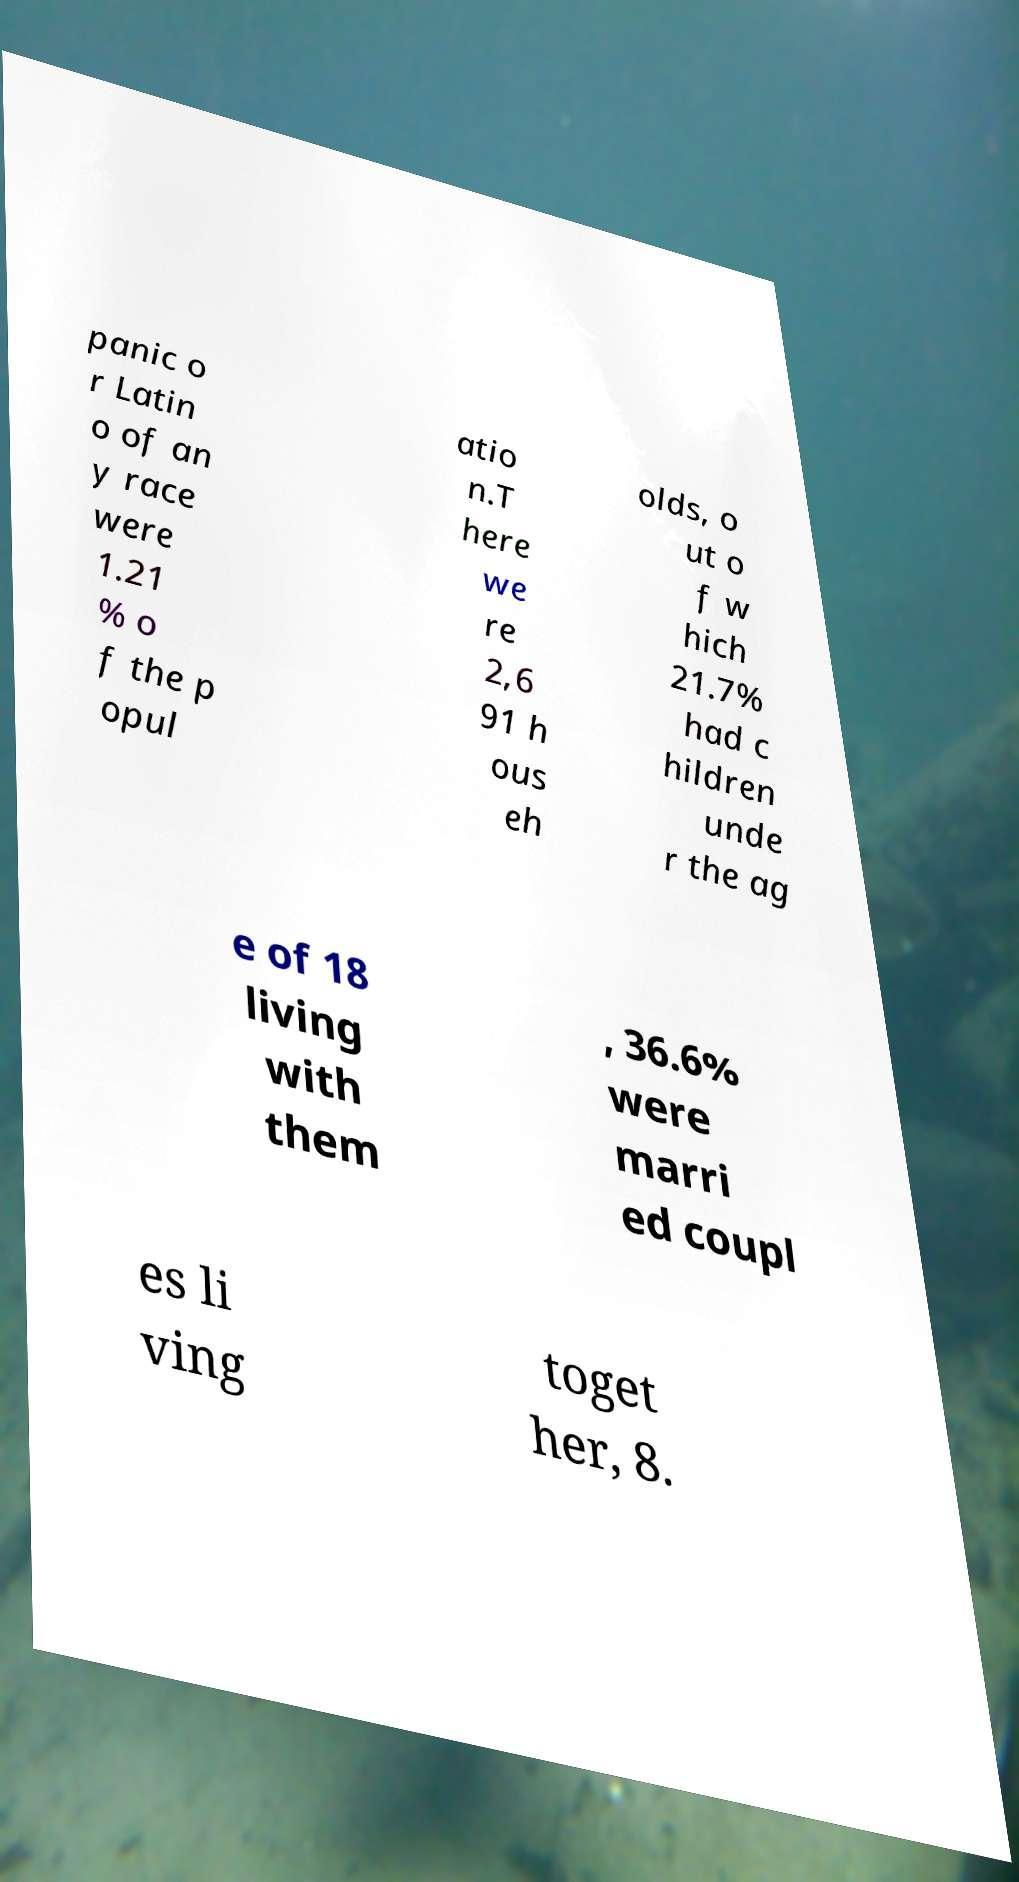Please read and relay the text visible in this image. What does it say? panic o r Latin o of an y race were 1.21 % o f the p opul atio n.T here we re 2,6 91 h ous eh olds, o ut o f w hich 21.7% had c hildren unde r the ag e of 18 living with them , 36.6% were marri ed coupl es li ving toget her, 8. 